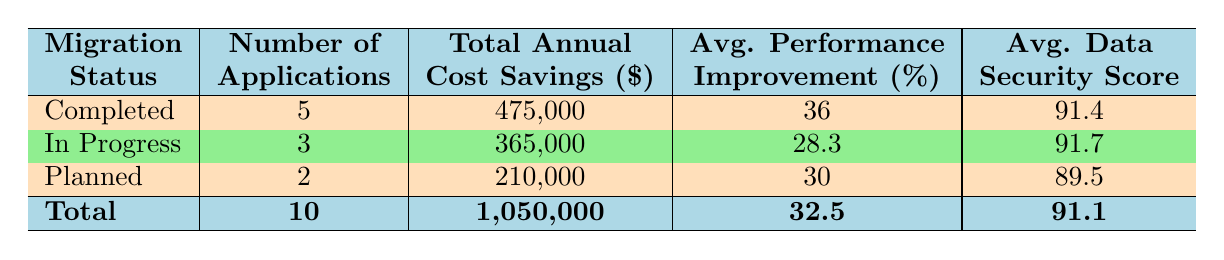What is the total annual cost savings for completed migrations? There are 5 applications under the "Completed" migration status. Summing their annual cost savings gives 250,000 + 75,000 + 50,000 + 60,000 + 40,000 = 475,000.
Answer: 475,000 How many applications are currently in progress? The table shows that 3 applications have a migration status of "In Progress."
Answer: 3 What is the average performance improvement for all applications? There are 10 applications in total. Their performance improvements are 35, 40, 25, 30, 20, 15, 45, 35, 30, and 50. Adding these gives 350, and dividing by 10 results in an average of 35.
Answer: 35 Is the data security score for completed migrations above 90? The average data security score for completed migrations is 91.4, which is above 90.
Answer: Yes What is the total number of applications and their combined cost savings for the "Planned" migration status? There are 2 applications under the "Planned" migration status. Their combined annual cost savings are 120,000 + 90,000 = 210,000.
Answer: 210,000 Which migration status has the highest average data security score? The "In Progress" status has an average data security score of 91.7, while "Completed" has 91.4 and "Planned" has 89.5. So "In Progress" has the highest score.
Answer: In Progress What is the difference in total annual cost savings between completed and planned migrations? The total annual cost savings for completed migrations is 475,000 and for planned migrations, it is 210,000. The difference is 475,000 - 210,000 = 265,000.
Answer: 265,000 What percentage of applications have completed their migration? There are 5 completed migrations out of a total of 10 applications. This gives 5/10 = 0.5, or 50 percent of applications completed their migration.
Answer: 50 percent Are there any applications with an annual cost savings under 40,000? The "Adobe Creative Suite" has an annual cost savings of 50,000, the "Zoom" has 40,000, and all others are above 40,000. Thus, there are no applications with savings under 40,000.
Answer: No 